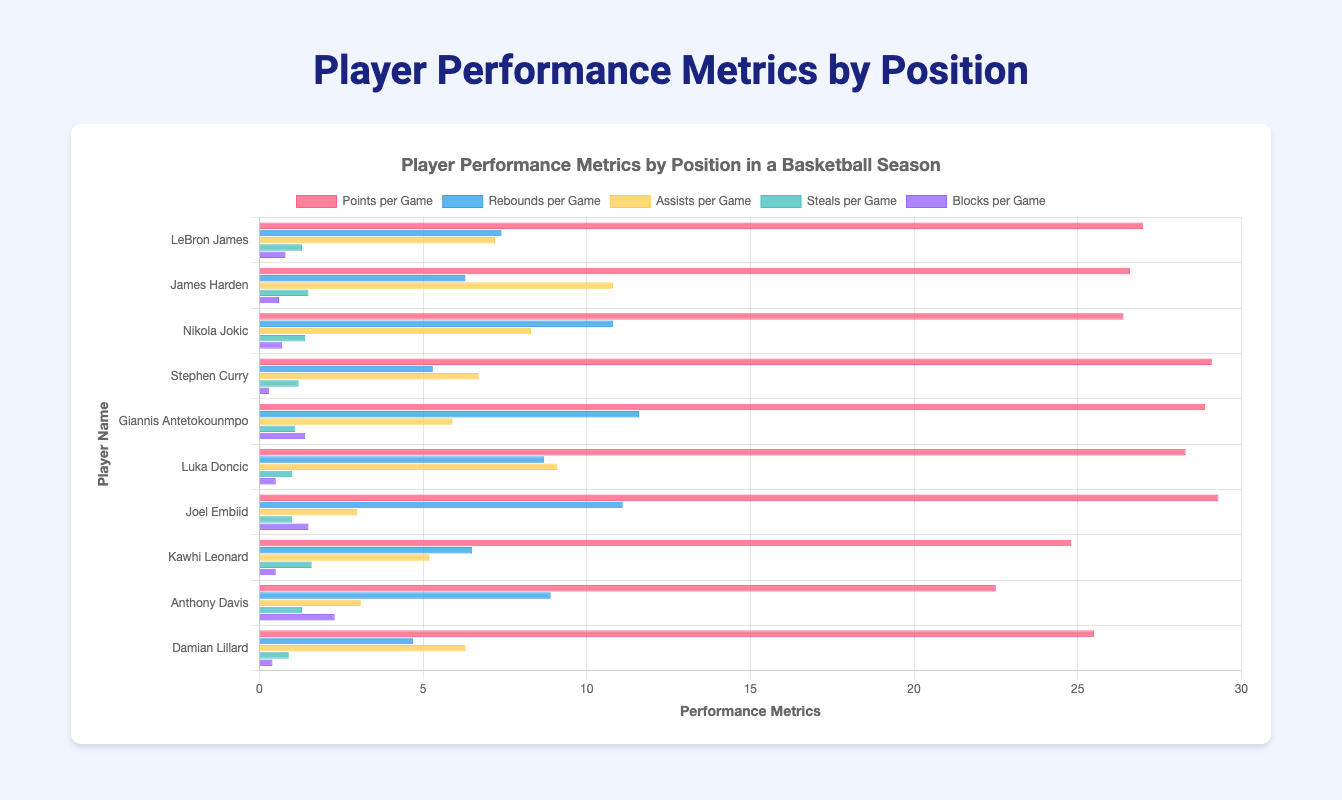what position does Nikola Jokic play? By looking at the tooltip or the label near Nikola Jokic's bar, you can see that his position is mentioned as "Center".
Answer: Center Which player scores the most points per game? By comparing the heights of the red bars representing 'Points per Game', we see that Joel Embiid's bar is the highest.
Answer: Joel Embiid Between LeBron James and Giannis Antetokounmpo, who has more rebounds per game? By comparing the heights of their blue bars representing 'Rebounds per Game', Giannis Antetokounmpo's bar is higher than LeBron James'.
Answer: Giannis Antetokounmpo Who has the highest number of assists per game among the point guards? Compare the heights of the yellow bars for Stephen Curry, Luka Doncic, and Damian Lillard. Luka Doncic's yellow bar is the highest.
Answer: Luka Doncic How many players have more than 2 blocks per game? Look for players whose purple bars extend above the 2-block marker. Only Anthony Davis surpasses this threshold.
Answer: One Who records the most steals per game? Compare the heights of the green bars. Kawhi Leonard's green bar is the highest.
Answer: Kawhi Leonard What is the total number of points per game for the top three scorers? The top three scoring players are Joel Embiid (29.3), Stephen Curry (29.1), and Giannis Antetokounmpo (28.9). Summing these gives 87.3.
Answer: 87.3 Which player has the lowest number of rebounds per game? Look for the shortest blue bar for 'Rebounds per Game'. Stephen Curry has the shortest blue bar.
Answer: Stephen Curry Is there any player who has the highest value in more than one metric? By examining each category, no single player leads in more than one metric across the whole chart.
Answer: No 